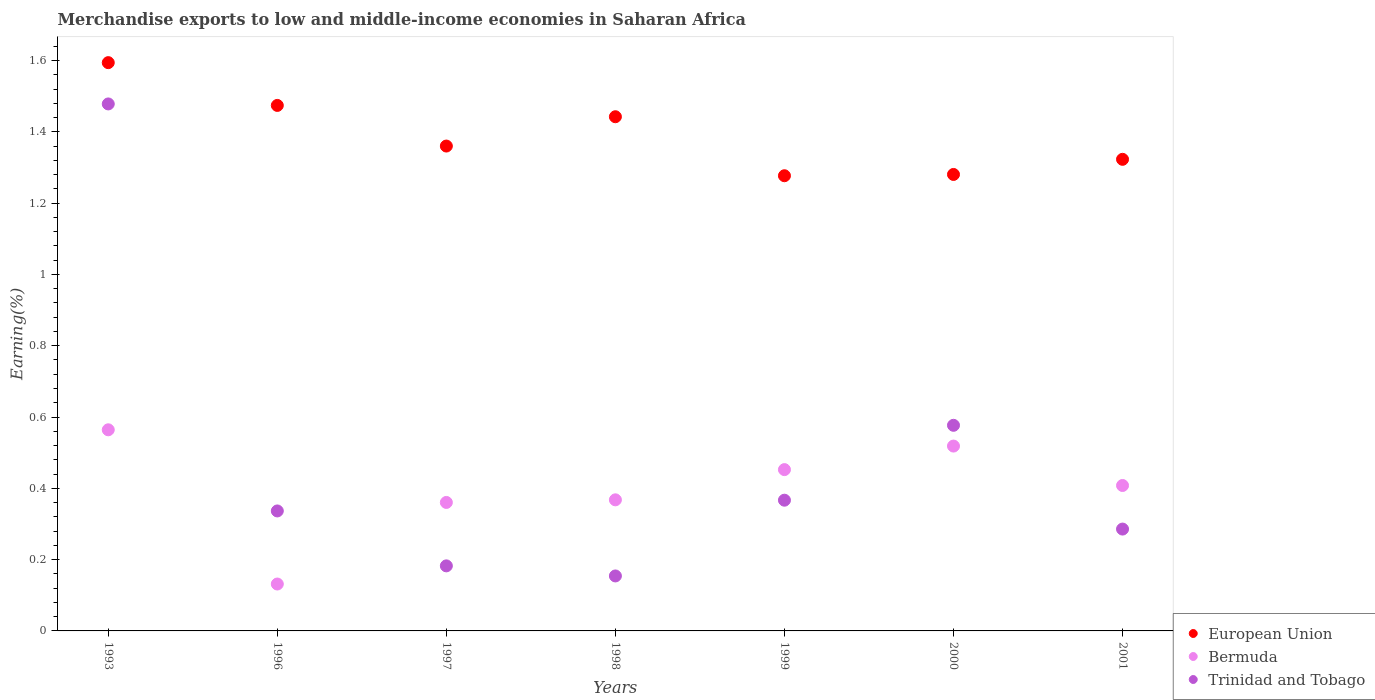How many different coloured dotlines are there?
Your answer should be very brief. 3. Is the number of dotlines equal to the number of legend labels?
Make the answer very short. Yes. What is the percentage of amount earned from merchandise exports in Bermuda in 1993?
Provide a succinct answer. 0.56. Across all years, what is the maximum percentage of amount earned from merchandise exports in Bermuda?
Provide a succinct answer. 0.56. Across all years, what is the minimum percentage of amount earned from merchandise exports in Bermuda?
Your answer should be very brief. 0.13. In which year was the percentage of amount earned from merchandise exports in Trinidad and Tobago maximum?
Give a very brief answer. 1993. What is the total percentage of amount earned from merchandise exports in Bermuda in the graph?
Ensure brevity in your answer.  2.8. What is the difference between the percentage of amount earned from merchandise exports in Trinidad and Tobago in 1997 and that in 2001?
Provide a short and direct response. -0.1. What is the difference between the percentage of amount earned from merchandise exports in European Union in 2001 and the percentage of amount earned from merchandise exports in Trinidad and Tobago in 1996?
Your answer should be very brief. 0.99. What is the average percentage of amount earned from merchandise exports in European Union per year?
Provide a succinct answer. 1.39. In the year 1999, what is the difference between the percentage of amount earned from merchandise exports in Bermuda and percentage of amount earned from merchandise exports in European Union?
Your answer should be compact. -0.82. What is the ratio of the percentage of amount earned from merchandise exports in Bermuda in 1993 to that in 1997?
Make the answer very short. 1.57. Is the percentage of amount earned from merchandise exports in European Union in 1993 less than that in 2000?
Make the answer very short. No. What is the difference between the highest and the second highest percentage of amount earned from merchandise exports in Trinidad and Tobago?
Provide a short and direct response. 0.9. What is the difference between the highest and the lowest percentage of amount earned from merchandise exports in Trinidad and Tobago?
Provide a succinct answer. 1.32. Is the sum of the percentage of amount earned from merchandise exports in Trinidad and Tobago in 1993 and 1997 greater than the maximum percentage of amount earned from merchandise exports in Bermuda across all years?
Provide a short and direct response. Yes. Is it the case that in every year, the sum of the percentage of amount earned from merchandise exports in European Union and percentage of amount earned from merchandise exports in Trinidad and Tobago  is greater than the percentage of amount earned from merchandise exports in Bermuda?
Keep it short and to the point. Yes. Are the values on the major ticks of Y-axis written in scientific E-notation?
Provide a short and direct response. No. Does the graph contain any zero values?
Your answer should be compact. No. Where does the legend appear in the graph?
Make the answer very short. Bottom right. How many legend labels are there?
Make the answer very short. 3. How are the legend labels stacked?
Ensure brevity in your answer.  Vertical. What is the title of the graph?
Your response must be concise. Merchandise exports to low and middle-income economies in Saharan Africa. Does "Moldova" appear as one of the legend labels in the graph?
Keep it short and to the point. No. What is the label or title of the Y-axis?
Give a very brief answer. Earning(%). What is the Earning(%) in European Union in 1993?
Your response must be concise. 1.59. What is the Earning(%) of Bermuda in 1993?
Your answer should be compact. 0.56. What is the Earning(%) of Trinidad and Tobago in 1993?
Provide a short and direct response. 1.48. What is the Earning(%) in European Union in 1996?
Ensure brevity in your answer.  1.47. What is the Earning(%) of Bermuda in 1996?
Keep it short and to the point. 0.13. What is the Earning(%) in Trinidad and Tobago in 1996?
Offer a terse response. 0.34. What is the Earning(%) of European Union in 1997?
Keep it short and to the point. 1.36. What is the Earning(%) of Bermuda in 1997?
Offer a very short reply. 0.36. What is the Earning(%) of Trinidad and Tobago in 1997?
Ensure brevity in your answer.  0.18. What is the Earning(%) in European Union in 1998?
Offer a terse response. 1.44. What is the Earning(%) of Bermuda in 1998?
Keep it short and to the point. 0.37. What is the Earning(%) in Trinidad and Tobago in 1998?
Your response must be concise. 0.15. What is the Earning(%) of European Union in 1999?
Keep it short and to the point. 1.28. What is the Earning(%) of Bermuda in 1999?
Offer a very short reply. 0.45. What is the Earning(%) in Trinidad and Tobago in 1999?
Ensure brevity in your answer.  0.37. What is the Earning(%) in European Union in 2000?
Offer a very short reply. 1.28. What is the Earning(%) in Bermuda in 2000?
Offer a very short reply. 0.52. What is the Earning(%) in Trinidad and Tobago in 2000?
Your response must be concise. 0.58. What is the Earning(%) in European Union in 2001?
Offer a terse response. 1.32. What is the Earning(%) in Bermuda in 2001?
Provide a short and direct response. 0.41. What is the Earning(%) in Trinidad and Tobago in 2001?
Make the answer very short. 0.29. Across all years, what is the maximum Earning(%) of European Union?
Make the answer very short. 1.59. Across all years, what is the maximum Earning(%) of Bermuda?
Give a very brief answer. 0.56. Across all years, what is the maximum Earning(%) of Trinidad and Tobago?
Offer a terse response. 1.48. Across all years, what is the minimum Earning(%) in European Union?
Give a very brief answer. 1.28. Across all years, what is the minimum Earning(%) of Bermuda?
Offer a terse response. 0.13. Across all years, what is the minimum Earning(%) of Trinidad and Tobago?
Make the answer very short. 0.15. What is the total Earning(%) in European Union in the graph?
Provide a succinct answer. 9.75. What is the total Earning(%) of Bermuda in the graph?
Provide a succinct answer. 2.8. What is the total Earning(%) of Trinidad and Tobago in the graph?
Your answer should be very brief. 3.38. What is the difference between the Earning(%) of European Union in 1993 and that in 1996?
Your response must be concise. 0.12. What is the difference between the Earning(%) in Bermuda in 1993 and that in 1996?
Provide a short and direct response. 0.43. What is the difference between the Earning(%) of Trinidad and Tobago in 1993 and that in 1996?
Provide a succinct answer. 1.14. What is the difference between the Earning(%) of European Union in 1993 and that in 1997?
Your answer should be compact. 0.23. What is the difference between the Earning(%) in Bermuda in 1993 and that in 1997?
Your response must be concise. 0.2. What is the difference between the Earning(%) of Trinidad and Tobago in 1993 and that in 1997?
Provide a short and direct response. 1.3. What is the difference between the Earning(%) in European Union in 1993 and that in 1998?
Make the answer very short. 0.15. What is the difference between the Earning(%) in Bermuda in 1993 and that in 1998?
Give a very brief answer. 0.2. What is the difference between the Earning(%) of Trinidad and Tobago in 1993 and that in 1998?
Keep it short and to the point. 1.32. What is the difference between the Earning(%) of European Union in 1993 and that in 1999?
Make the answer very short. 0.32. What is the difference between the Earning(%) of Bermuda in 1993 and that in 1999?
Provide a succinct answer. 0.11. What is the difference between the Earning(%) of Trinidad and Tobago in 1993 and that in 1999?
Your answer should be compact. 1.11. What is the difference between the Earning(%) of European Union in 1993 and that in 2000?
Provide a short and direct response. 0.31. What is the difference between the Earning(%) in Bermuda in 1993 and that in 2000?
Offer a terse response. 0.05. What is the difference between the Earning(%) in Trinidad and Tobago in 1993 and that in 2000?
Your answer should be compact. 0.9. What is the difference between the Earning(%) of European Union in 1993 and that in 2001?
Keep it short and to the point. 0.27. What is the difference between the Earning(%) in Bermuda in 1993 and that in 2001?
Offer a very short reply. 0.16. What is the difference between the Earning(%) of Trinidad and Tobago in 1993 and that in 2001?
Your answer should be very brief. 1.19. What is the difference between the Earning(%) in European Union in 1996 and that in 1997?
Offer a terse response. 0.11. What is the difference between the Earning(%) of Bermuda in 1996 and that in 1997?
Provide a succinct answer. -0.23. What is the difference between the Earning(%) in Trinidad and Tobago in 1996 and that in 1997?
Keep it short and to the point. 0.15. What is the difference between the Earning(%) in European Union in 1996 and that in 1998?
Provide a succinct answer. 0.03. What is the difference between the Earning(%) of Bermuda in 1996 and that in 1998?
Give a very brief answer. -0.24. What is the difference between the Earning(%) in Trinidad and Tobago in 1996 and that in 1998?
Keep it short and to the point. 0.18. What is the difference between the Earning(%) in European Union in 1996 and that in 1999?
Provide a succinct answer. 0.2. What is the difference between the Earning(%) in Bermuda in 1996 and that in 1999?
Offer a terse response. -0.32. What is the difference between the Earning(%) of Trinidad and Tobago in 1996 and that in 1999?
Ensure brevity in your answer.  -0.03. What is the difference between the Earning(%) of European Union in 1996 and that in 2000?
Your answer should be compact. 0.19. What is the difference between the Earning(%) in Bermuda in 1996 and that in 2000?
Your answer should be very brief. -0.39. What is the difference between the Earning(%) of Trinidad and Tobago in 1996 and that in 2000?
Provide a succinct answer. -0.24. What is the difference between the Earning(%) in European Union in 1996 and that in 2001?
Offer a terse response. 0.15. What is the difference between the Earning(%) of Bermuda in 1996 and that in 2001?
Your answer should be very brief. -0.28. What is the difference between the Earning(%) of Trinidad and Tobago in 1996 and that in 2001?
Make the answer very short. 0.05. What is the difference between the Earning(%) in European Union in 1997 and that in 1998?
Provide a succinct answer. -0.08. What is the difference between the Earning(%) in Bermuda in 1997 and that in 1998?
Your answer should be very brief. -0.01. What is the difference between the Earning(%) in Trinidad and Tobago in 1997 and that in 1998?
Your answer should be compact. 0.03. What is the difference between the Earning(%) in European Union in 1997 and that in 1999?
Make the answer very short. 0.08. What is the difference between the Earning(%) in Bermuda in 1997 and that in 1999?
Give a very brief answer. -0.09. What is the difference between the Earning(%) in Trinidad and Tobago in 1997 and that in 1999?
Make the answer very short. -0.18. What is the difference between the Earning(%) of European Union in 1997 and that in 2000?
Your response must be concise. 0.08. What is the difference between the Earning(%) of Bermuda in 1997 and that in 2000?
Ensure brevity in your answer.  -0.16. What is the difference between the Earning(%) in Trinidad and Tobago in 1997 and that in 2000?
Give a very brief answer. -0.39. What is the difference between the Earning(%) of European Union in 1997 and that in 2001?
Provide a succinct answer. 0.04. What is the difference between the Earning(%) of Bermuda in 1997 and that in 2001?
Your answer should be compact. -0.05. What is the difference between the Earning(%) of Trinidad and Tobago in 1997 and that in 2001?
Make the answer very short. -0.1. What is the difference between the Earning(%) of European Union in 1998 and that in 1999?
Ensure brevity in your answer.  0.17. What is the difference between the Earning(%) of Bermuda in 1998 and that in 1999?
Your answer should be compact. -0.08. What is the difference between the Earning(%) in Trinidad and Tobago in 1998 and that in 1999?
Provide a short and direct response. -0.21. What is the difference between the Earning(%) in European Union in 1998 and that in 2000?
Keep it short and to the point. 0.16. What is the difference between the Earning(%) of Bermuda in 1998 and that in 2000?
Keep it short and to the point. -0.15. What is the difference between the Earning(%) in Trinidad and Tobago in 1998 and that in 2000?
Keep it short and to the point. -0.42. What is the difference between the Earning(%) of European Union in 1998 and that in 2001?
Provide a succinct answer. 0.12. What is the difference between the Earning(%) in Bermuda in 1998 and that in 2001?
Ensure brevity in your answer.  -0.04. What is the difference between the Earning(%) of Trinidad and Tobago in 1998 and that in 2001?
Provide a short and direct response. -0.13. What is the difference between the Earning(%) of European Union in 1999 and that in 2000?
Your response must be concise. -0. What is the difference between the Earning(%) in Bermuda in 1999 and that in 2000?
Make the answer very short. -0.07. What is the difference between the Earning(%) in Trinidad and Tobago in 1999 and that in 2000?
Offer a terse response. -0.21. What is the difference between the Earning(%) of European Union in 1999 and that in 2001?
Offer a terse response. -0.05. What is the difference between the Earning(%) of Bermuda in 1999 and that in 2001?
Your answer should be compact. 0.04. What is the difference between the Earning(%) in Trinidad and Tobago in 1999 and that in 2001?
Make the answer very short. 0.08. What is the difference between the Earning(%) of European Union in 2000 and that in 2001?
Offer a terse response. -0.04. What is the difference between the Earning(%) of Bermuda in 2000 and that in 2001?
Give a very brief answer. 0.11. What is the difference between the Earning(%) in Trinidad and Tobago in 2000 and that in 2001?
Offer a very short reply. 0.29. What is the difference between the Earning(%) of European Union in 1993 and the Earning(%) of Bermuda in 1996?
Offer a very short reply. 1.46. What is the difference between the Earning(%) in European Union in 1993 and the Earning(%) in Trinidad and Tobago in 1996?
Keep it short and to the point. 1.26. What is the difference between the Earning(%) of Bermuda in 1993 and the Earning(%) of Trinidad and Tobago in 1996?
Keep it short and to the point. 0.23. What is the difference between the Earning(%) in European Union in 1993 and the Earning(%) in Bermuda in 1997?
Offer a terse response. 1.23. What is the difference between the Earning(%) of European Union in 1993 and the Earning(%) of Trinidad and Tobago in 1997?
Provide a succinct answer. 1.41. What is the difference between the Earning(%) in Bermuda in 1993 and the Earning(%) in Trinidad and Tobago in 1997?
Ensure brevity in your answer.  0.38. What is the difference between the Earning(%) in European Union in 1993 and the Earning(%) in Bermuda in 1998?
Your answer should be very brief. 1.23. What is the difference between the Earning(%) of European Union in 1993 and the Earning(%) of Trinidad and Tobago in 1998?
Your response must be concise. 1.44. What is the difference between the Earning(%) in Bermuda in 1993 and the Earning(%) in Trinidad and Tobago in 1998?
Offer a very short reply. 0.41. What is the difference between the Earning(%) in European Union in 1993 and the Earning(%) in Bermuda in 1999?
Offer a very short reply. 1.14. What is the difference between the Earning(%) of European Union in 1993 and the Earning(%) of Trinidad and Tobago in 1999?
Offer a terse response. 1.23. What is the difference between the Earning(%) of Bermuda in 1993 and the Earning(%) of Trinidad and Tobago in 1999?
Ensure brevity in your answer.  0.2. What is the difference between the Earning(%) of European Union in 1993 and the Earning(%) of Bermuda in 2000?
Make the answer very short. 1.08. What is the difference between the Earning(%) of European Union in 1993 and the Earning(%) of Trinidad and Tobago in 2000?
Your answer should be compact. 1.02. What is the difference between the Earning(%) in Bermuda in 1993 and the Earning(%) in Trinidad and Tobago in 2000?
Ensure brevity in your answer.  -0.01. What is the difference between the Earning(%) of European Union in 1993 and the Earning(%) of Bermuda in 2001?
Provide a short and direct response. 1.19. What is the difference between the Earning(%) in European Union in 1993 and the Earning(%) in Trinidad and Tobago in 2001?
Your response must be concise. 1.31. What is the difference between the Earning(%) in Bermuda in 1993 and the Earning(%) in Trinidad and Tobago in 2001?
Your response must be concise. 0.28. What is the difference between the Earning(%) of European Union in 1996 and the Earning(%) of Bermuda in 1997?
Your response must be concise. 1.11. What is the difference between the Earning(%) of European Union in 1996 and the Earning(%) of Trinidad and Tobago in 1997?
Your answer should be compact. 1.29. What is the difference between the Earning(%) in Bermuda in 1996 and the Earning(%) in Trinidad and Tobago in 1997?
Give a very brief answer. -0.05. What is the difference between the Earning(%) in European Union in 1996 and the Earning(%) in Bermuda in 1998?
Offer a very short reply. 1.11. What is the difference between the Earning(%) of European Union in 1996 and the Earning(%) of Trinidad and Tobago in 1998?
Your answer should be very brief. 1.32. What is the difference between the Earning(%) in Bermuda in 1996 and the Earning(%) in Trinidad and Tobago in 1998?
Offer a very short reply. -0.02. What is the difference between the Earning(%) in European Union in 1996 and the Earning(%) in Bermuda in 1999?
Your response must be concise. 1.02. What is the difference between the Earning(%) in European Union in 1996 and the Earning(%) in Trinidad and Tobago in 1999?
Your response must be concise. 1.11. What is the difference between the Earning(%) of Bermuda in 1996 and the Earning(%) of Trinidad and Tobago in 1999?
Provide a succinct answer. -0.24. What is the difference between the Earning(%) of European Union in 1996 and the Earning(%) of Bermuda in 2000?
Keep it short and to the point. 0.96. What is the difference between the Earning(%) in European Union in 1996 and the Earning(%) in Trinidad and Tobago in 2000?
Keep it short and to the point. 0.9. What is the difference between the Earning(%) of Bermuda in 1996 and the Earning(%) of Trinidad and Tobago in 2000?
Your answer should be compact. -0.45. What is the difference between the Earning(%) in European Union in 1996 and the Earning(%) in Bermuda in 2001?
Make the answer very short. 1.07. What is the difference between the Earning(%) of European Union in 1996 and the Earning(%) of Trinidad and Tobago in 2001?
Ensure brevity in your answer.  1.19. What is the difference between the Earning(%) of Bermuda in 1996 and the Earning(%) of Trinidad and Tobago in 2001?
Give a very brief answer. -0.15. What is the difference between the Earning(%) of European Union in 1997 and the Earning(%) of Bermuda in 1998?
Provide a succinct answer. 0.99. What is the difference between the Earning(%) of European Union in 1997 and the Earning(%) of Trinidad and Tobago in 1998?
Your answer should be very brief. 1.21. What is the difference between the Earning(%) of Bermuda in 1997 and the Earning(%) of Trinidad and Tobago in 1998?
Give a very brief answer. 0.21. What is the difference between the Earning(%) of European Union in 1997 and the Earning(%) of Bermuda in 1999?
Offer a very short reply. 0.91. What is the difference between the Earning(%) in European Union in 1997 and the Earning(%) in Trinidad and Tobago in 1999?
Your response must be concise. 0.99. What is the difference between the Earning(%) of Bermuda in 1997 and the Earning(%) of Trinidad and Tobago in 1999?
Your response must be concise. -0.01. What is the difference between the Earning(%) of European Union in 1997 and the Earning(%) of Bermuda in 2000?
Ensure brevity in your answer.  0.84. What is the difference between the Earning(%) of European Union in 1997 and the Earning(%) of Trinidad and Tobago in 2000?
Your response must be concise. 0.78. What is the difference between the Earning(%) of Bermuda in 1997 and the Earning(%) of Trinidad and Tobago in 2000?
Your response must be concise. -0.22. What is the difference between the Earning(%) of European Union in 1997 and the Earning(%) of Bermuda in 2001?
Offer a terse response. 0.95. What is the difference between the Earning(%) in European Union in 1997 and the Earning(%) in Trinidad and Tobago in 2001?
Your response must be concise. 1.07. What is the difference between the Earning(%) of Bermuda in 1997 and the Earning(%) of Trinidad and Tobago in 2001?
Your response must be concise. 0.07. What is the difference between the Earning(%) in European Union in 1998 and the Earning(%) in Trinidad and Tobago in 1999?
Your answer should be compact. 1.08. What is the difference between the Earning(%) in Bermuda in 1998 and the Earning(%) in Trinidad and Tobago in 1999?
Offer a very short reply. 0. What is the difference between the Earning(%) of European Union in 1998 and the Earning(%) of Bermuda in 2000?
Offer a very short reply. 0.92. What is the difference between the Earning(%) in European Union in 1998 and the Earning(%) in Trinidad and Tobago in 2000?
Your response must be concise. 0.87. What is the difference between the Earning(%) of Bermuda in 1998 and the Earning(%) of Trinidad and Tobago in 2000?
Keep it short and to the point. -0.21. What is the difference between the Earning(%) in European Union in 1998 and the Earning(%) in Bermuda in 2001?
Provide a succinct answer. 1.03. What is the difference between the Earning(%) in European Union in 1998 and the Earning(%) in Trinidad and Tobago in 2001?
Give a very brief answer. 1.16. What is the difference between the Earning(%) of Bermuda in 1998 and the Earning(%) of Trinidad and Tobago in 2001?
Offer a terse response. 0.08. What is the difference between the Earning(%) of European Union in 1999 and the Earning(%) of Bermuda in 2000?
Ensure brevity in your answer.  0.76. What is the difference between the Earning(%) of European Union in 1999 and the Earning(%) of Trinidad and Tobago in 2000?
Offer a very short reply. 0.7. What is the difference between the Earning(%) in Bermuda in 1999 and the Earning(%) in Trinidad and Tobago in 2000?
Offer a very short reply. -0.12. What is the difference between the Earning(%) of European Union in 1999 and the Earning(%) of Bermuda in 2001?
Your answer should be compact. 0.87. What is the difference between the Earning(%) of Bermuda in 1999 and the Earning(%) of Trinidad and Tobago in 2001?
Make the answer very short. 0.17. What is the difference between the Earning(%) of European Union in 2000 and the Earning(%) of Bermuda in 2001?
Give a very brief answer. 0.87. What is the difference between the Earning(%) of Bermuda in 2000 and the Earning(%) of Trinidad and Tobago in 2001?
Provide a short and direct response. 0.23. What is the average Earning(%) in European Union per year?
Your answer should be compact. 1.39. What is the average Earning(%) of Bermuda per year?
Keep it short and to the point. 0.4. What is the average Earning(%) in Trinidad and Tobago per year?
Your answer should be very brief. 0.48. In the year 1993, what is the difference between the Earning(%) in European Union and Earning(%) in Trinidad and Tobago?
Your answer should be compact. 0.12. In the year 1993, what is the difference between the Earning(%) in Bermuda and Earning(%) in Trinidad and Tobago?
Your response must be concise. -0.91. In the year 1996, what is the difference between the Earning(%) of European Union and Earning(%) of Bermuda?
Your response must be concise. 1.34. In the year 1996, what is the difference between the Earning(%) of European Union and Earning(%) of Trinidad and Tobago?
Make the answer very short. 1.14. In the year 1996, what is the difference between the Earning(%) of Bermuda and Earning(%) of Trinidad and Tobago?
Offer a terse response. -0.2. In the year 1997, what is the difference between the Earning(%) of European Union and Earning(%) of Trinidad and Tobago?
Your answer should be compact. 1.18. In the year 1997, what is the difference between the Earning(%) in Bermuda and Earning(%) in Trinidad and Tobago?
Give a very brief answer. 0.18. In the year 1998, what is the difference between the Earning(%) of European Union and Earning(%) of Bermuda?
Make the answer very short. 1.07. In the year 1998, what is the difference between the Earning(%) in European Union and Earning(%) in Trinidad and Tobago?
Your answer should be very brief. 1.29. In the year 1998, what is the difference between the Earning(%) of Bermuda and Earning(%) of Trinidad and Tobago?
Offer a very short reply. 0.21. In the year 1999, what is the difference between the Earning(%) in European Union and Earning(%) in Bermuda?
Your response must be concise. 0.82. In the year 1999, what is the difference between the Earning(%) in European Union and Earning(%) in Trinidad and Tobago?
Your answer should be compact. 0.91. In the year 1999, what is the difference between the Earning(%) of Bermuda and Earning(%) of Trinidad and Tobago?
Offer a very short reply. 0.09. In the year 2000, what is the difference between the Earning(%) of European Union and Earning(%) of Bermuda?
Provide a succinct answer. 0.76. In the year 2000, what is the difference between the Earning(%) in European Union and Earning(%) in Trinidad and Tobago?
Offer a terse response. 0.7. In the year 2000, what is the difference between the Earning(%) in Bermuda and Earning(%) in Trinidad and Tobago?
Your answer should be very brief. -0.06. In the year 2001, what is the difference between the Earning(%) in European Union and Earning(%) in Bermuda?
Provide a succinct answer. 0.92. In the year 2001, what is the difference between the Earning(%) in European Union and Earning(%) in Trinidad and Tobago?
Your answer should be very brief. 1.04. In the year 2001, what is the difference between the Earning(%) of Bermuda and Earning(%) of Trinidad and Tobago?
Your response must be concise. 0.12. What is the ratio of the Earning(%) in European Union in 1993 to that in 1996?
Your response must be concise. 1.08. What is the ratio of the Earning(%) in Bermuda in 1993 to that in 1996?
Provide a short and direct response. 4.29. What is the ratio of the Earning(%) of Trinidad and Tobago in 1993 to that in 1996?
Offer a very short reply. 4.39. What is the ratio of the Earning(%) in European Union in 1993 to that in 1997?
Your response must be concise. 1.17. What is the ratio of the Earning(%) of Bermuda in 1993 to that in 1997?
Give a very brief answer. 1.57. What is the ratio of the Earning(%) of Trinidad and Tobago in 1993 to that in 1997?
Provide a succinct answer. 8.1. What is the ratio of the Earning(%) of European Union in 1993 to that in 1998?
Your response must be concise. 1.11. What is the ratio of the Earning(%) of Bermuda in 1993 to that in 1998?
Make the answer very short. 1.53. What is the ratio of the Earning(%) in Trinidad and Tobago in 1993 to that in 1998?
Offer a very short reply. 9.59. What is the ratio of the Earning(%) of European Union in 1993 to that in 1999?
Your answer should be very brief. 1.25. What is the ratio of the Earning(%) in Bermuda in 1993 to that in 1999?
Offer a very short reply. 1.25. What is the ratio of the Earning(%) in Trinidad and Tobago in 1993 to that in 1999?
Offer a terse response. 4.03. What is the ratio of the Earning(%) in European Union in 1993 to that in 2000?
Give a very brief answer. 1.24. What is the ratio of the Earning(%) of Bermuda in 1993 to that in 2000?
Your response must be concise. 1.09. What is the ratio of the Earning(%) in Trinidad and Tobago in 1993 to that in 2000?
Keep it short and to the point. 2.56. What is the ratio of the Earning(%) of European Union in 1993 to that in 2001?
Your answer should be compact. 1.21. What is the ratio of the Earning(%) of Bermuda in 1993 to that in 2001?
Provide a short and direct response. 1.38. What is the ratio of the Earning(%) of Trinidad and Tobago in 1993 to that in 2001?
Offer a very short reply. 5.17. What is the ratio of the Earning(%) of European Union in 1996 to that in 1997?
Make the answer very short. 1.08. What is the ratio of the Earning(%) of Bermuda in 1996 to that in 1997?
Your answer should be very brief. 0.37. What is the ratio of the Earning(%) of Trinidad and Tobago in 1996 to that in 1997?
Keep it short and to the point. 1.84. What is the ratio of the Earning(%) of European Union in 1996 to that in 1998?
Your answer should be compact. 1.02. What is the ratio of the Earning(%) of Bermuda in 1996 to that in 1998?
Offer a very short reply. 0.36. What is the ratio of the Earning(%) in Trinidad and Tobago in 1996 to that in 1998?
Offer a very short reply. 2.18. What is the ratio of the Earning(%) of European Union in 1996 to that in 1999?
Your answer should be very brief. 1.15. What is the ratio of the Earning(%) of Bermuda in 1996 to that in 1999?
Provide a short and direct response. 0.29. What is the ratio of the Earning(%) of Trinidad and Tobago in 1996 to that in 1999?
Offer a terse response. 0.92. What is the ratio of the Earning(%) in European Union in 1996 to that in 2000?
Provide a short and direct response. 1.15. What is the ratio of the Earning(%) in Bermuda in 1996 to that in 2000?
Provide a short and direct response. 0.25. What is the ratio of the Earning(%) in Trinidad and Tobago in 1996 to that in 2000?
Keep it short and to the point. 0.58. What is the ratio of the Earning(%) in European Union in 1996 to that in 2001?
Ensure brevity in your answer.  1.11. What is the ratio of the Earning(%) of Bermuda in 1996 to that in 2001?
Keep it short and to the point. 0.32. What is the ratio of the Earning(%) in Trinidad and Tobago in 1996 to that in 2001?
Your response must be concise. 1.18. What is the ratio of the Earning(%) of European Union in 1997 to that in 1998?
Offer a very short reply. 0.94. What is the ratio of the Earning(%) in Bermuda in 1997 to that in 1998?
Offer a terse response. 0.98. What is the ratio of the Earning(%) of Trinidad and Tobago in 1997 to that in 1998?
Your answer should be very brief. 1.18. What is the ratio of the Earning(%) in European Union in 1997 to that in 1999?
Provide a succinct answer. 1.07. What is the ratio of the Earning(%) of Bermuda in 1997 to that in 1999?
Your answer should be very brief. 0.8. What is the ratio of the Earning(%) in Trinidad and Tobago in 1997 to that in 1999?
Provide a succinct answer. 0.5. What is the ratio of the Earning(%) in European Union in 1997 to that in 2000?
Keep it short and to the point. 1.06. What is the ratio of the Earning(%) in Bermuda in 1997 to that in 2000?
Your answer should be compact. 0.69. What is the ratio of the Earning(%) in Trinidad and Tobago in 1997 to that in 2000?
Your answer should be compact. 0.32. What is the ratio of the Earning(%) of European Union in 1997 to that in 2001?
Provide a short and direct response. 1.03. What is the ratio of the Earning(%) of Bermuda in 1997 to that in 2001?
Make the answer very short. 0.88. What is the ratio of the Earning(%) of Trinidad and Tobago in 1997 to that in 2001?
Your answer should be compact. 0.64. What is the ratio of the Earning(%) in European Union in 1998 to that in 1999?
Ensure brevity in your answer.  1.13. What is the ratio of the Earning(%) of Bermuda in 1998 to that in 1999?
Your answer should be compact. 0.81. What is the ratio of the Earning(%) in Trinidad and Tobago in 1998 to that in 1999?
Your response must be concise. 0.42. What is the ratio of the Earning(%) of European Union in 1998 to that in 2000?
Your answer should be compact. 1.13. What is the ratio of the Earning(%) of Bermuda in 1998 to that in 2000?
Give a very brief answer. 0.71. What is the ratio of the Earning(%) in Trinidad and Tobago in 1998 to that in 2000?
Ensure brevity in your answer.  0.27. What is the ratio of the Earning(%) of European Union in 1998 to that in 2001?
Offer a very short reply. 1.09. What is the ratio of the Earning(%) of Bermuda in 1998 to that in 2001?
Your response must be concise. 0.9. What is the ratio of the Earning(%) of Trinidad and Tobago in 1998 to that in 2001?
Provide a short and direct response. 0.54. What is the ratio of the Earning(%) of Bermuda in 1999 to that in 2000?
Offer a terse response. 0.87. What is the ratio of the Earning(%) of Trinidad and Tobago in 1999 to that in 2000?
Provide a short and direct response. 0.64. What is the ratio of the Earning(%) in European Union in 1999 to that in 2001?
Give a very brief answer. 0.97. What is the ratio of the Earning(%) of Bermuda in 1999 to that in 2001?
Keep it short and to the point. 1.11. What is the ratio of the Earning(%) in Trinidad and Tobago in 1999 to that in 2001?
Make the answer very short. 1.28. What is the ratio of the Earning(%) in European Union in 2000 to that in 2001?
Give a very brief answer. 0.97. What is the ratio of the Earning(%) of Bermuda in 2000 to that in 2001?
Offer a very short reply. 1.27. What is the ratio of the Earning(%) in Trinidad and Tobago in 2000 to that in 2001?
Provide a short and direct response. 2.02. What is the difference between the highest and the second highest Earning(%) in European Union?
Ensure brevity in your answer.  0.12. What is the difference between the highest and the second highest Earning(%) in Bermuda?
Provide a short and direct response. 0.05. What is the difference between the highest and the second highest Earning(%) of Trinidad and Tobago?
Keep it short and to the point. 0.9. What is the difference between the highest and the lowest Earning(%) of European Union?
Ensure brevity in your answer.  0.32. What is the difference between the highest and the lowest Earning(%) in Bermuda?
Offer a terse response. 0.43. What is the difference between the highest and the lowest Earning(%) of Trinidad and Tobago?
Give a very brief answer. 1.32. 